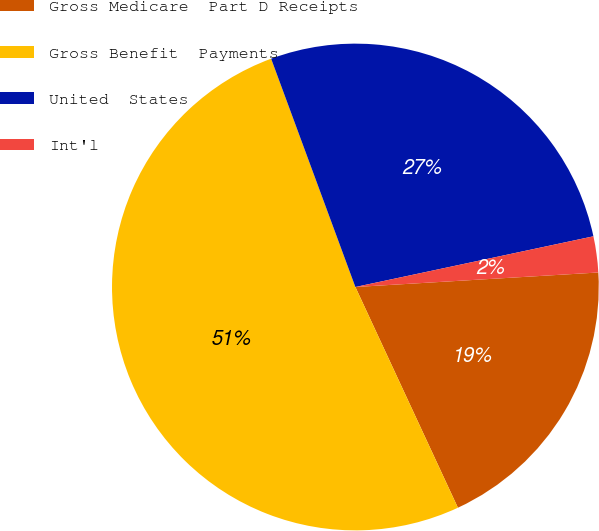Convert chart to OTSL. <chart><loc_0><loc_0><loc_500><loc_500><pie_chart><fcel>Gross Medicare  Part D Receipts<fcel>Gross Benefit  Payments<fcel>United  States<fcel>Int'l<nl><fcel>19.03%<fcel>51.3%<fcel>27.29%<fcel>2.39%<nl></chart> 